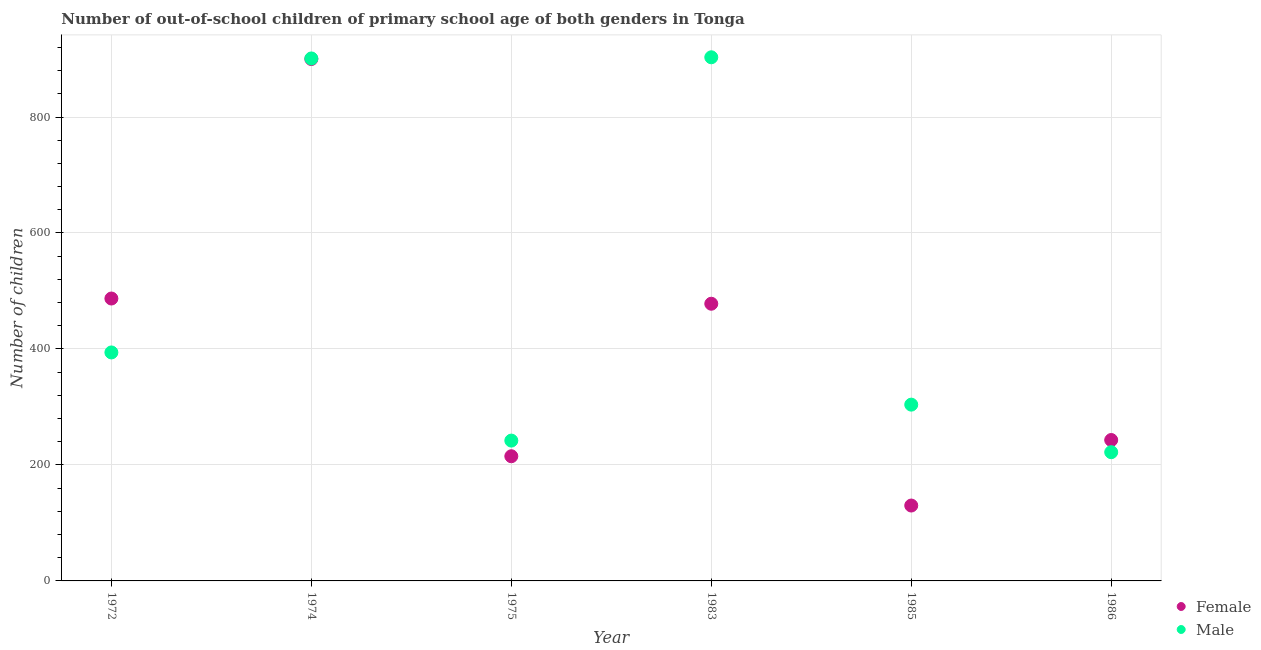How many different coloured dotlines are there?
Provide a succinct answer. 2. What is the number of male out-of-school students in 1983?
Your answer should be very brief. 903. Across all years, what is the maximum number of male out-of-school students?
Your response must be concise. 903. Across all years, what is the minimum number of male out-of-school students?
Your response must be concise. 222. What is the total number of male out-of-school students in the graph?
Provide a succinct answer. 2966. What is the difference between the number of female out-of-school students in 1985 and that in 1986?
Give a very brief answer. -113. What is the difference between the number of female out-of-school students in 1985 and the number of male out-of-school students in 1972?
Make the answer very short. -264. What is the average number of female out-of-school students per year?
Provide a succinct answer. 408.83. In the year 1974, what is the difference between the number of female out-of-school students and number of male out-of-school students?
Give a very brief answer. -1. What is the ratio of the number of female out-of-school students in 1983 to that in 1985?
Make the answer very short. 3.68. Is the number of male out-of-school students in 1975 less than that in 1986?
Your response must be concise. No. Is the difference between the number of female out-of-school students in 1983 and 1986 greater than the difference between the number of male out-of-school students in 1983 and 1986?
Make the answer very short. No. What is the difference between the highest and the second highest number of female out-of-school students?
Give a very brief answer. 413. What is the difference between the highest and the lowest number of female out-of-school students?
Make the answer very short. 770. Is the number of male out-of-school students strictly greater than the number of female out-of-school students over the years?
Your answer should be compact. No. What is the difference between two consecutive major ticks on the Y-axis?
Offer a terse response. 200. Are the values on the major ticks of Y-axis written in scientific E-notation?
Offer a very short reply. No. Does the graph contain any zero values?
Provide a short and direct response. No. Does the graph contain grids?
Your answer should be very brief. Yes. How many legend labels are there?
Offer a very short reply. 2. How are the legend labels stacked?
Your answer should be compact. Vertical. What is the title of the graph?
Keep it short and to the point. Number of out-of-school children of primary school age of both genders in Tonga. What is the label or title of the X-axis?
Offer a terse response. Year. What is the label or title of the Y-axis?
Your answer should be compact. Number of children. What is the Number of children of Female in 1972?
Provide a short and direct response. 487. What is the Number of children of Male in 1972?
Your answer should be very brief. 394. What is the Number of children of Female in 1974?
Keep it short and to the point. 900. What is the Number of children of Male in 1974?
Provide a succinct answer. 901. What is the Number of children in Female in 1975?
Your answer should be compact. 215. What is the Number of children in Male in 1975?
Provide a succinct answer. 242. What is the Number of children in Female in 1983?
Provide a succinct answer. 478. What is the Number of children of Male in 1983?
Your answer should be very brief. 903. What is the Number of children of Female in 1985?
Give a very brief answer. 130. What is the Number of children in Male in 1985?
Ensure brevity in your answer.  304. What is the Number of children in Female in 1986?
Make the answer very short. 243. What is the Number of children in Male in 1986?
Provide a short and direct response. 222. Across all years, what is the maximum Number of children of Female?
Your answer should be very brief. 900. Across all years, what is the maximum Number of children of Male?
Offer a terse response. 903. Across all years, what is the minimum Number of children of Female?
Ensure brevity in your answer.  130. Across all years, what is the minimum Number of children of Male?
Offer a terse response. 222. What is the total Number of children of Female in the graph?
Provide a succinct answer. 2453. What is the total Number of children in Male in the graph?
Keep it short and to the point. 2966. What is the difference between the Number of children of Female in 1972 and that in 1974?
Offer a terse response. -413. What is the difference between the Number of children in Male in 1972 and that in 1974?
Give a very brief answer. -507. What is the difference between the Number of children in Female in 1972 and that in 1975?
Provide a succinct answer. 272. What is the difference between the Number of children in Male in 1972 and that in 1975?
Keep it short and to the point. 152. What is the difference between the Number of children of Female in 1972 and that in 1983?
Your answer should be compact. 9. What is the difference between the Number of children in Male in 1972 and that in 1983?
Make the answer very short. -509. What is the difference between the Number of children in Female in 1972 and that in 1985?
Offer a very short reply. 357. What is the difference between the Number of children of Female in 1972 and that in 1986?
Your response must be concise. 244. What is the difference between the Number of children in Male in 1972 and that in 1986?
Provide a succinct answer. 172. What is the difference between the Number of children in Female in 1974 and that in 1975?
Give a very brief answer. 685. What is the difference between the Number of children of Male in 1974 and that in 1975?
Your answer should be very brief. 659. What is the difference between the Number of children of Female in 1974 and that in 1983?
Give a very brief answer. 422. What is the difference between the Number of children in Male in 1974 and that in 1983?
Keep it short and to the point. -2. What is the difference between the Number of children in Female in 1974 and that in 1985?
Offer a terse response. 770. What is the difference between the Number of children in Male in 1974 and that in 1985?
Make the answer very short. 597. What is the difference between the Number of children of Female in 1974 and that in 1986?
Provide a short and direct response. 657. What is the difference between the Number of children of Male in 1974 and that in 1986?
Offer a terse response. 679. What is the difference between the Number of children in Female in 1975 and that in 1983?
Offer a terse response. -263. What is the difference between the Number of children in Male in 1975 and that in 1983?
Offer a terse response. -661. What is the difference between the Number of children of Female in 1975 and that in 1985?
Your answer should be very brief. 85. What is the difference between the Number of children of Male in 1975 and that in 1985?
Your response must be concise. -62. What is the difference between the Number of children of Female in 1983 and that in 1985?
Keep it short and to the point. 348. What is the difference between the Number of children in Male in 1983 and that in 1985?
Make the answer very short. 599. What is the difference between the Number of children in Female in 1983 and that in 1986?
Your answer should be very brief. 235. What is the difference between the Number of children in Male in 1983 and that in 1986?
Provide a short and direct response. 681. What is the difference between the Number of children of Female in 1985 and that in 1986?
Offer a terse response. -113. What is the difference between the Number of children of Female in 1972 and the Number of children of Male in 1974?
Provide a succinct answer. -414. What is the difference between the Number of children of Female in 1972 and the Number of children of Male in 1975?
Keep it short and to the point. 245. What is the difference between the Number of children of Female in 1972 and the Number of children of Male in 1983?
Offer a very short reply. -416. What is the difference between the Number of children in Female in 1972 and the Number of children in Male in 1985?
Make the answer very short. 183. What is the difference between the Number of children in Female in 1972 and the Number of children in Male in 1986?
Provide a short and direct response. 265. What is the difference between the Number of children of Female in 1974 and the Number of children of Male in 1975?
Ensure brevity in your answer.  658. What is the difference between the Number of children of Female in 1974 and the Number of children of Male in 1985?
Provide a short and direct response. 596. What is the difference between the Number of children of Female in 1974 and the Number of children of Male in 1986?
Provide a succinct answer. 678. What is the difference between the Number of children of Female in 1975 and the Number of children of Male in 1983?
Provide a short and direct response. -688. What is the difference between the Number of children of Female in 1975 and the Number of children of Male in 1985?
Ensure brevity in your answer.  -89. What is the difference between the Number of children of Female in 1975 and the Number of children of Male in 1986?
Offer a terse response. -7. What is the difference between the Number of children of Female in 1983 and the Number of children of Male in 1985?
Make the answer very short. 174. What is the difference between the Number of children of Female in 1983 and the Number of children of Male in 1986?
Your answer should be compact. 256. What is the difference between the Number of children of Female in 1985 and the Number of children of Male in 1986?
Your answer should be compact. -92. What is the average Number of children in Female per year?
Provide a succinct answer. 408.83. What is the average Number of children in Male per year?
Give a very brief answer. 494.33. In the year 1972, what is the difference between the Number of children of Female and Number of children of Male?
Provide a short and direct response. 93. In the year 1983, what is the difference between the Number of children in Female and Number of children in Male?
Your response must be concise. -425. In the year 1985, what is the difference between the Number of children of Female and Number of children of Male?
Ensure brevity in your answer.  -174. In the year 1986, what is the difference between the Number of children of Female and Number of children of Male?
Your answer should be compact. 21. What is the ratio of the Number of children in Female in 1972 to that in 1974?
Keep it short and to the point. 0.54. What is the ratio of the Number of children in Male in 1972 to that in 1974?
Keep it short and to the point. 0.44. What is the ratio of the Number of children in Female in 1972 to that in 1975?
Your answer should be very brief. 2.27. What is the ratio of the Number of children of Male in 1972 to that in 1975?
Make the answer very short. 1.63. What is the ratio of the Number of children in Female in 1972 to that in 1983?
Ensure brevity in your answer.  1.02. What is the ratio of the Number of children in Male in 1972 to that in 1983?
Offer a very short reply. 0.44. What is the ratio of the Number of children of Female in 1972 to that in 1985?
Offer a terse response. 3.75. What is the ratio of the Number of children in Male in 1972 to that in 1985?
Give a very brief answer. 1.3. What is the ratio of the Number of children in Female in 1972 to that in 1986?
Provide a short and direct response. 2. What is the ratio of the Number of children of Male in 1972 to that in 1986?
Offer a very short reply. 1.77. What is the ratio of the Number of children in Female in 1974 to that in 1975?
Your answer should be very brief. 4.19. What is the ratio of the Number of children in Male in 1974 to that in 1975?
Offer a very short reply. 3.72. What is the ratio of the Number of children of Female in 1974 to that in 1983?
Your answer should be compact. 1.88. What is the ratio of the Number of children in Female in 1974 to that in 1985?
Your answer should be very brief. 6.92. What is the ratio of the Number of children of Male in 1974 to that in 1985?
Your answer should be compact. 2.96. What is the ratio of the Number of children in Female in 1974 to that in 1986?
Offer a very short reply. 3.7. What is the ratio of the Number of children of Male in 1974 to that in 1986?
Make the answer very short. 4.06. What is the ratio of the Number of children in Female in 1975 to that in 1983?
Offer a terse response. 0.45. What is the ratio of the Number of children of Male in 1975 to that in 1983?
Provide a succinct answer. 0.27. What is the ratio of the Number of children in Female in 1975 to that in 1985?
Provide a short and direct response. 1.65. What is the ratio of the Number of children in Male in 1975 to that in 1985?
Offer a terse response. 0.8. What is the ratio of the Number of children of Female in 1975 to that in 1986?
Offer a very short reply. 0.88. What is the ratio of the Number of children of Male in 1975 to that in 1986?
Your answer should be very brief. 1.09. What is the ratio of the Number of children of Female in 1983 to that in 1985?
Provide a succinct answer. 3.68. What is the ratio of the Number of children in Male in 1983 to that in 1985?
Your answer should be compact. 2.97. What is the ratio of the Number of children in Female in 1983 to that in 1986?
Provide a short and direct response. 1.97. What is the ratio of the Number of children in Male in 1983 to that in 1986?
Your answer should be very brief. 4.07. What is the ratio of the Number of children of Female in 1985 to that in 1986?
Provide a short and direct response. 0.54. What is the ratio of the Number of children of Male in 1985 to that in 1986?
Offer a very short reply. 1.37. What is the difference between the highest and the second highest Number of children of Female?
Make the answer very short. 413. What is the difference between the highest and the lowest Number of children of Female?
Keep it short and to the point. 770. What is the difference between the highest and the lowest Number of children in Male?
Ensure brevity in your answer.  681. 